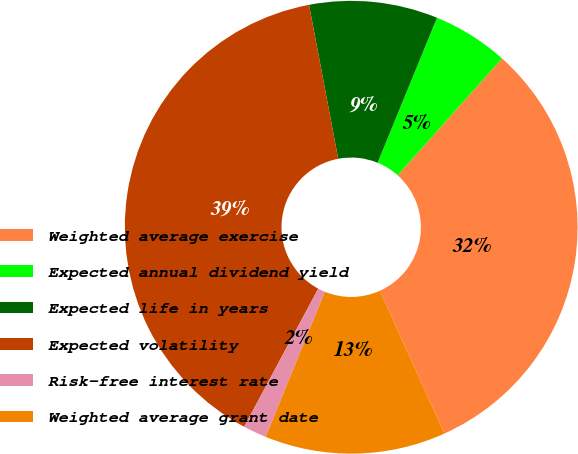Convert chart to OTSL. <chart><loc_0><loc_0><loc_500><loc_500><pie_chart><fcel>Weighted average exercise<fcel>Expected annual dividend yield<fcel>Expected life in years<fcel>Expected volatility<fcel>Risk-free interest rate<fcel>Weighted average grant date<nl><fcel>31.64%<fcel>5.42%<fcel>9.17%<fcel>39.18%<fcel>1.67%<fcel>12.92%<nl></chart> 